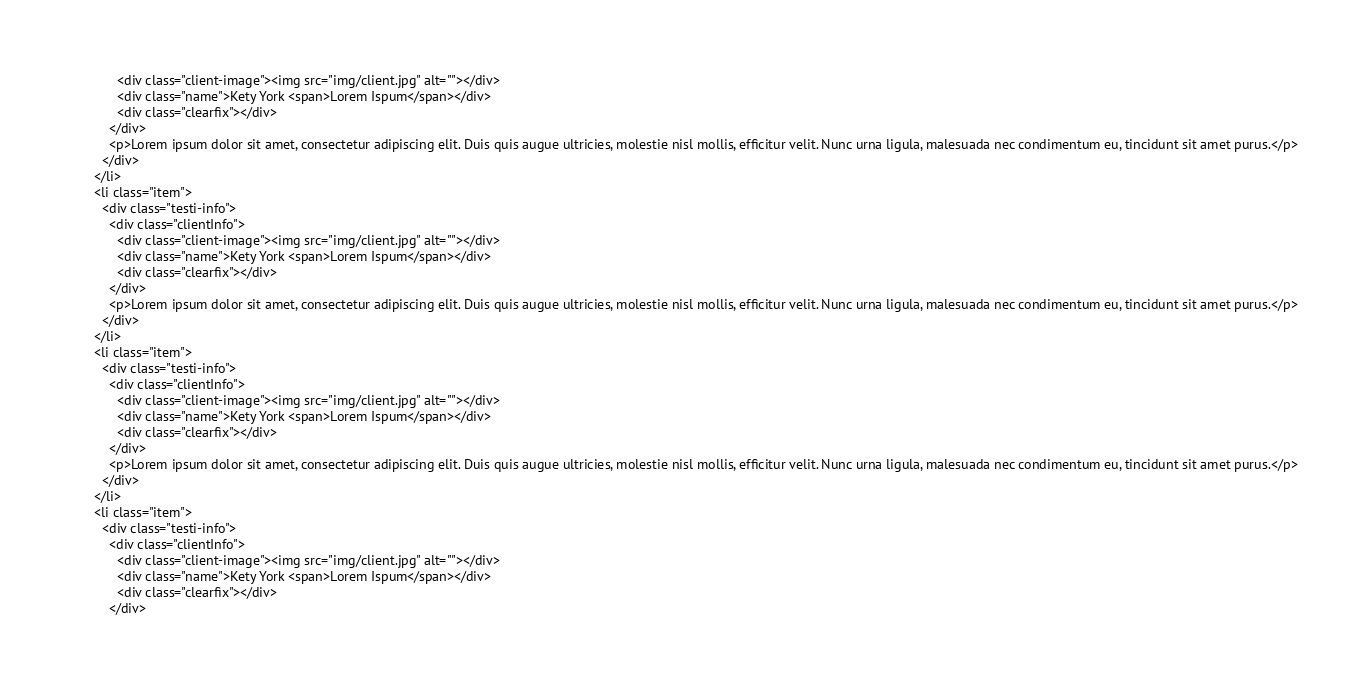<code> <loc_0><loc_0><loc_500><loc_500><_PHP_>            <div class="client-image"><img src="img/client.jpg" alt=""></div>
            <div class="name">Kety York <span>Lorem Ispum</span></div>
            <div class="clearfix"></div>
          </div>
          <p>Lorem ipsum dolor sit amet, consectetur adipiscing elit. Duis quis augue ultricies, molestie nisl mollis, efficitur velit. Nunc urna ligula, malesuada nec condimentum eu, tincidunt sit amet purus.</p>
        </div>
      </li>
      <li class="item">
        <div class="testi-info">
          <div class="clientInfo">
            <div class="client-image"><img src="img/client.jpg" alt=""></div>
            <div class="name">Kety York <span>Lorem Ispum</span></div>
            <div class="clearfix"></div>
          </div>
          <p>Lorem ipsum dolor sit amet, consectetur adipiscing elit. Duis quis augue ultricies, molestie nisl mollis, efficitur velit. Nunc urna ligula, malesuada nec condimentum eu, tincidunt sit amet purus.</p>
        </div>
      </li>
      <li class="item">
        <div class="testi-info">
          <div class="clientInfo">
            <div class="client-image"><img src="img/client.jpg" alt=""></div>
            <div class="name">Kety York <span>Lorem Ispum</span></div>
            <div class="clearfix"></div>
          </div>
          <p>Lorem ipsum dolor sit amet, consectetur adipiscing elit. Duis quis augue ultricies, molestie nisl mollis, efficitur velit. Nunc urna ligula, malesuada nec condimentum eu, tincidunt sit amet purus.</p>
        </div>
      </li>
      <li class="item">
        <div class="testi-info">
          <div class="clientInfo">
            <div class="client-image"><img src="img/client.jpg" alt=""></div>
            <div class="name">Kety York <span>Lorem Ispum</span></div>
            <div class="clearfix"></div>
          </div></code> 